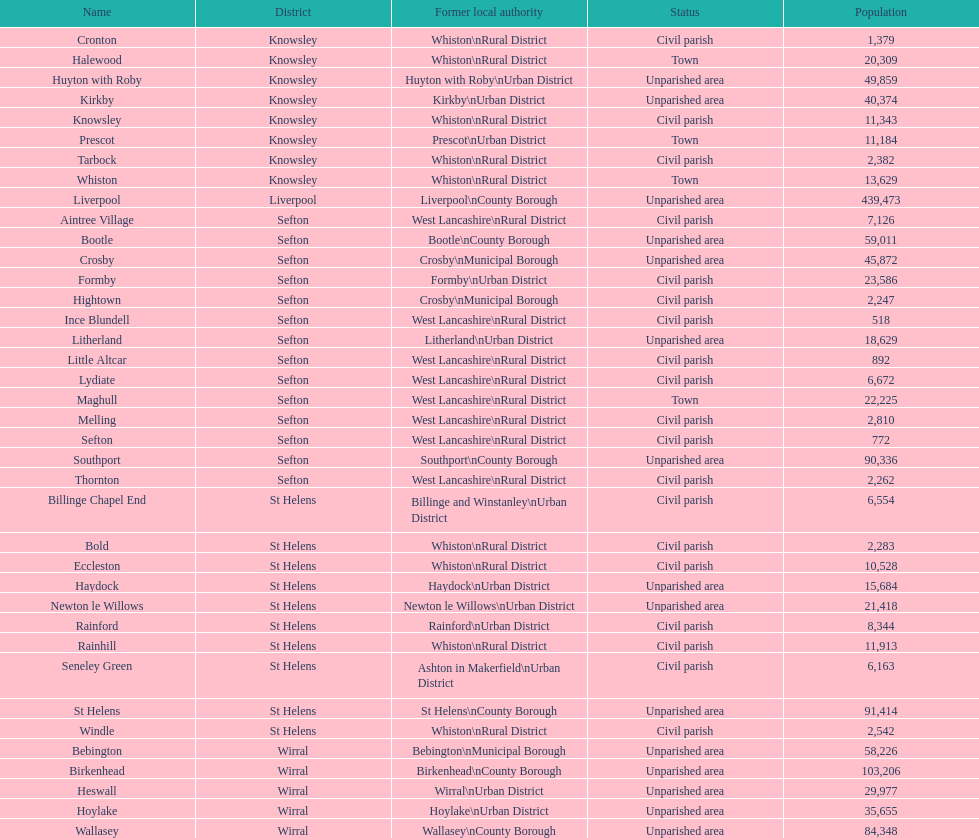What is the largest area in terms of population? Liverpool. 